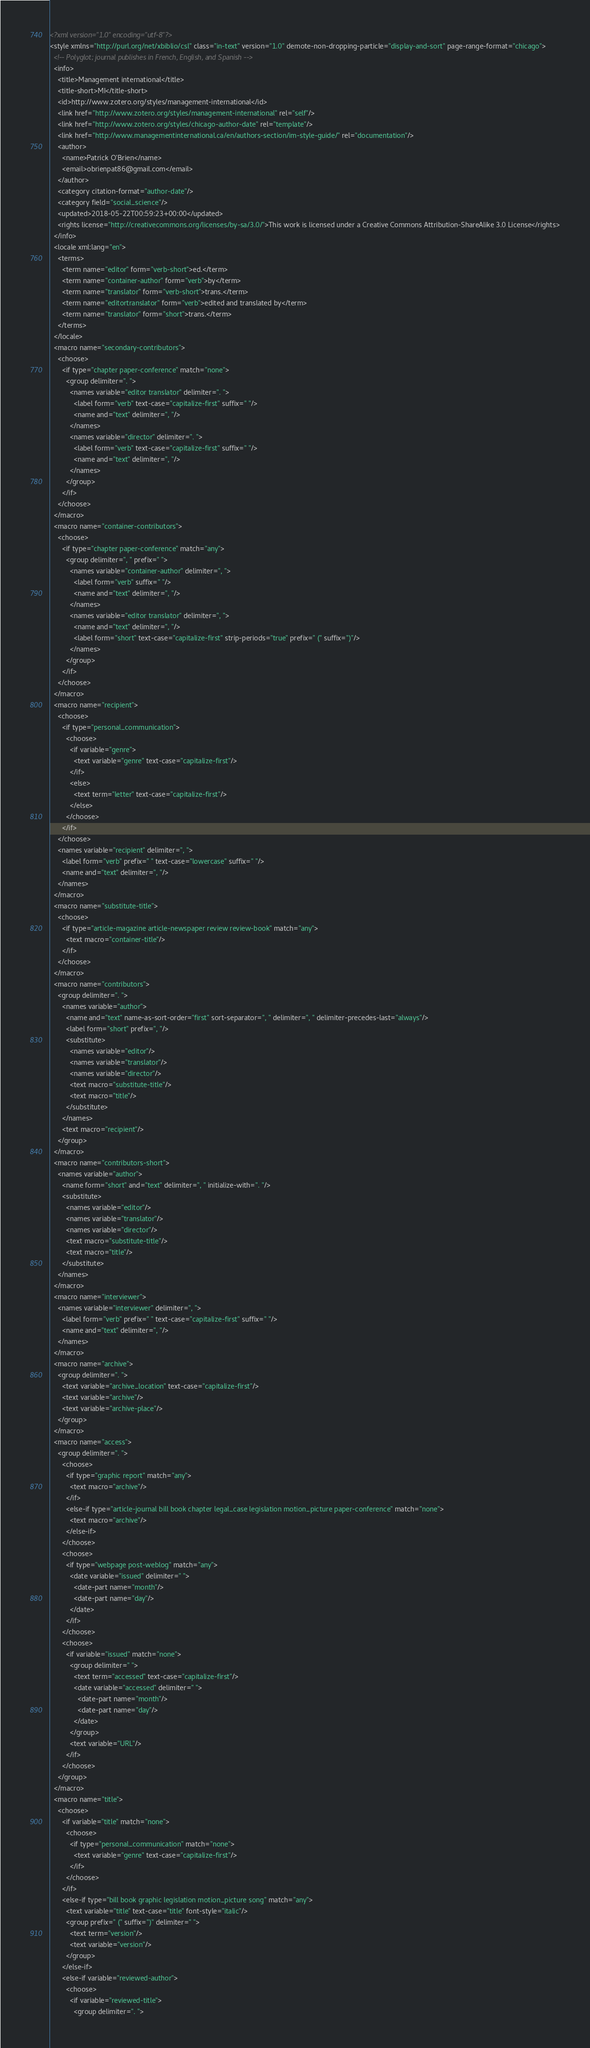Convert code to text. <code><loc_0><loc_0><loc_500><loc_500><_XML_><?xml version="1.0" encoding="utf-8"?>
<style xmlns="http://purl.org/net/xbiblio/csl" class="in-text" version="1.0" demote-non-dropping-particle="display-and-sort" page-range-format="chicago">
  <!-- Polyglot; journal publishes in French, English, and Spanish -->
  <info>
    <title>Management international</title>
    <title-short>MI</title-short>
    <id>http://www.zotero.org/styles/management-international</id>
    <link href="http://www.zotero.org/styles/management-international" rel="self"/>
    <link href="http://www.zotero.org/styles/chicago-author-date" rel="template"/>
    <link href="http://www.managementinternational.ca/en/authors-section/im-style-guide/" rel="documentation"/>
    <author>
      <name>Patrick O'Brien</name>
      <email>obrienpat86@gmail.com</email>
    </author>
    <category citation-format="author-date"/>
    <category field="social_science"/>
    <updated>2018-05-22T00:59:23+00:00</updated>
    <rights license="http://creativecommons.org/licenses/by-sa/3.0/">This work is licensed under a Creative Commons Attribution-ShareAlike 3.0 License</rights>
  </info>
  <locale xml:lang="en">
    <terms>
      <term name="editor" form="verb-short">ed.</term>
      <term name="container-author" form="verb">by</term>
      <term name="translator" form="verb-short">trans.</term>
      <term name="editortranslator" form="verb">edited and translated by</term>
      <term name="translator" form="short">trans.</term>
    </terms>
  </locale>
  <macro name="secondary-contributors">
    <choose>
      <if type="chapter paper-conference" match="none">
        <group delimiter=". ">
          <names variable="editor translator" delimiter=". ">
            <label form="verb" text-case="capitalize-first" suffix=" "/>
            <name and="text" delimiter=", "/>
          </names>
          <names variable="director" delimiter=". ">
            <label form="verb" text-case="capitalize-first" suffix=" "/>
            <name and="text" delimiter=", "/>
          </names>
        </group>
      </if>
    </choose>
  </macro>
  <macro name="container-contributors">
    <choose>
      <if type="chapter paper-conference" match="any">
        <group delimiter=", " prefix=" ">
          <names variable="container-author" delimiter=", ">
            <label form="verb" suffix=" "/>
            <name and="text" delimiter=", "/>
          </names>
          <names variable="editor translator" delimiter=", ">
            <name and="text" delimiter=", "/>
            <label form="short" text-case="capitalize-first" strip-periods="true" prefix=" (" suffix=")"/>
          </names>
        </group>
      </if>
    </choose>
  </macro>
  <macro name="recipient">
    <choose>
      <if type="personal_communication">
        <choose>
          <if variable="genre">
            <text variable="genre" text-case="capitalize-first"/>
          </if>
          <else>
            <text term="letter" text-case="capitalize-first"/>
          </else>
        </choose>
      </if>
    </choose>
    <names variable="recipient" delimiter=", ">
      <label form="verb" prefix=" " text-case="lowercase" suffix=" "/>
      <name and="text" delimiter=", "/>
    </names>
  </macro>
  <macro name="substitute-title">
    <choose>
      <if type="article-magazine article-newspaper review review-book" match="any">
        <text macro="container-title"/>
      </if>
    </choose>
  </macro>
  <macro name="contributors">
    <group delimiter=". ">
      <names variable="author">
        <name and="text" name-as-sort-order="first" sort-separator=", " delimiter=", " delimiter-precedes-last="always"/>
        <label form="short" prefix=", "/>
        <substitute>
          <names variable="editor"/>
          <names variable="translator"/>
          <names variable="director"/>
          <text macro="substitute-title"/>
          <text macro="title"/>
        </substitute>
      </names>
      <text macro="recipient"/>
    </group>
  </macro>
  <macro name="contributors-short">
    <names variable="author">
      <name form="short" and="text" delimiter=", " initialize-with=". "/>
      <substitute>
        <names variable="editor"/>
        <names variable="translator"/>
        <names variable="director"/>
        <text macro="substitute-title"/>
        <text macro="title"/>
      </substitute>
    </names>
  </macro>
  <macro name="interviewer">
    <names variable="interviewer" delimiter=", ">
      <label form="verb" prefix=" " text-case="capitalize-first" suffix=" "/>
      <name and="text" delimiter=", "/>
    </names>
  </macro>
  <macro name="archive">
    <group delimiter=". ">
      <text variable="archive_location" text-case="capitalize-first"/>
      <text variable="archive"/>
      <text variable="archive-place"/>
    </group>
  </macro>
  <macro name="access">
    <group delimiter=". ">
      <choose>
        <if type="graphic report" match="any">
          <text macro="archive"/>
        </if>
        <else-if type="article-journal bill book chapter legal_case legislation motion_picture paper-conference" match="none">
          <text macro="archive"/>
        </else-if>
      </choose>
      <choose>
        <if type="webpage post-weblog" match="any">
          <date variable="issued" delimiter=" ">
            <date-part name="month"/>
            <date-part name="day"/>
          </date>
        </if>
      </choose>
      <choose>
        <if variable="issued" match="none">
          <group delimiter=" ">
            <text term="accessed" text-case="capitalize-first"/>
            <date variable="accessed" delimiter=" ">
              <date-part name="month"/>
              <date-part name="day"/>
            </date>
          </group>
          <text variable="URL"/>
        </if>
      </choose>
    </group>
  </macro>
  <macro name="title">
    <choose>
      <if variable="title" match="none">
        <choose>
          <if type="personal_communication" match="none">
            <text variable="genre" text-case="capitalize-first"/>
          </if>
        </choose>
      </if>
      <else-if type="bill book graphic legislation motion_picture song" match="any">
        <text variable="title" text-case="title" font-style="italic"/>
        <group prefix=" (" suffix=")" delimiter=" ">
          <text term="version"/>
          <text variable="version"/>
        </group>
      </else-if>
      <else-if variable="reviewed-author">
        <choose>
          <if variable="reviewed-title">
            <group delimiter=". "></code> 